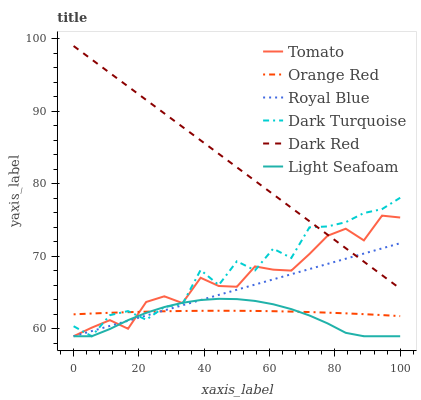Does Light Seafoam have the minimum area under the curve?
Answer yes or no. Yes. Does Dark Red have the maximum area under the curve?
Answer yes or no. Yes. Does Royal Blue have the minimum area under the curve?
Answer yes or no. No. Does Royal Blue have the maximum area under the curve?
Answer yes or no. No. Is Royal Blue the smoothest?
Answer yes or no. Yes. Is Dark Turquoise the roughest?
Answer yes or no. Yes. Is Dark Red the smoothest?
Answer yes or no. No. Is Dark Red the roughest?
Answer yes or no. No. Does Tomato have the lowest value?
Answer yes or no. Yes. Does Dark Red have the lowest value?
Answer yes or no. No. Does Dark Red have the highest value?
Answer yes or no. Yes. Does Royal Blue have the highest value?
Answer yes or no. No. Is Light Seafoam less than Dark Red?
Answer yes or no. Yes. Is Dark Red greater than Orange Red?
Answer yes or no. Yes. Does Royal Blue intersect Light Seafoam?
Answer yes or no. Yes. Is Royal Blue less than Light Seafoam?
Answer yes or no. No. Is Royal Blue greater than Light Seafoam?
Answer yes or no. No. Does Light Seafoam intersect Dark Red?
Answer yes or no. No. 